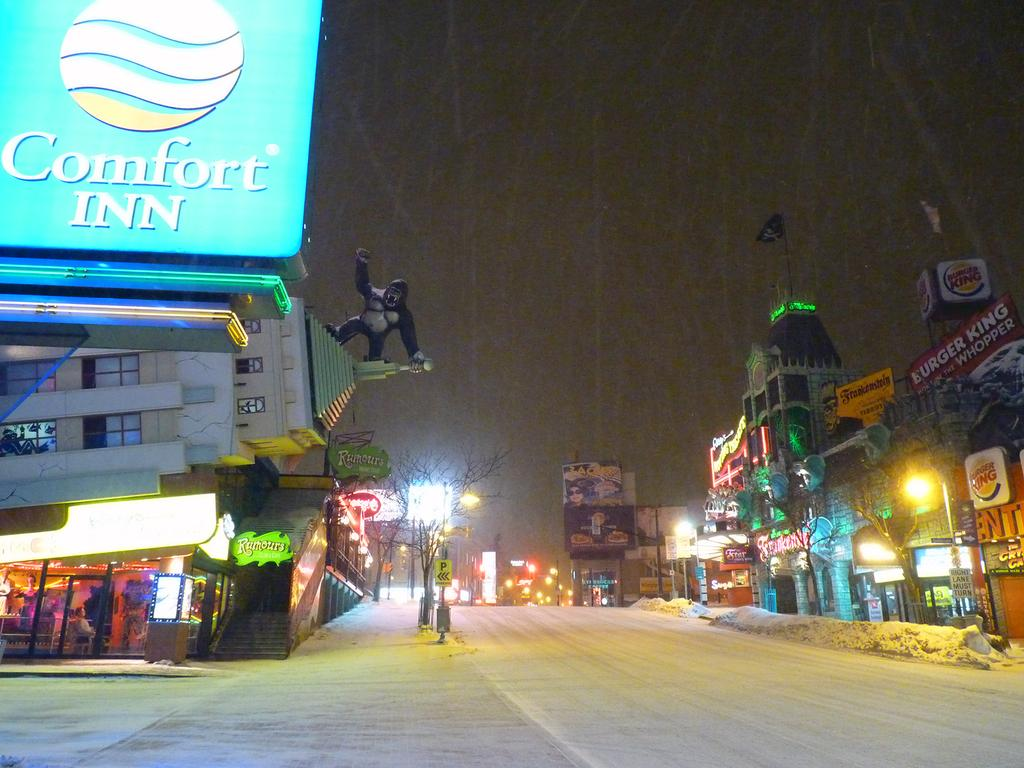What type of structures can be seen in the image? There are buildings in the image. What other natural elements are present in the image? There are trees in the image. Are there any artificial light sources visible in the image? Yes, there are lights in the image. What is the condition of the road in the image? The road has snow on it in the image. Where is the board located in the image? The board is at the top left side of the image. What can be seen in the background of the image? The sky is visible in the background of the image. What type of education is being offered by the suit in the image? There is no suit present in the image, and therefore no education can be associated with it. What shape is the circle in the image? There is no circle present in the image. 